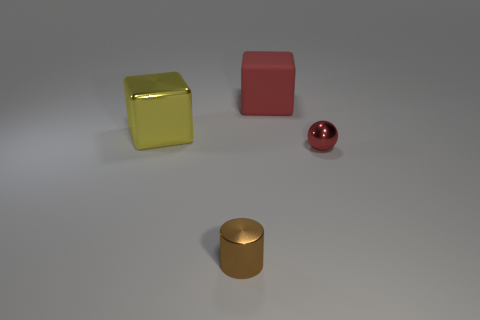There is another thing that is the same shape as the large yellow shiny object; what is its color?
Ensure brevity in your answer.  Red. What color is the large block that is made of the same material as the ball?
Your answer should be compact. Yellow. How many cylinders are the same size as the red sphere?
Make the answer very short. 1. What is the large yellow cube made of?
Make the answer very short. Metal. Are there more tiny brown metal cylinders than tiny blue metallic blocks?
Give a very brief answer. Yes. Does the tiny red metal object have the same shape as the large yellow object?
Give a very brief answer. No. Are there any other things that are the same shape as the brown thing?
Offer a very short reply. No. Do the big block that is to the right of the metallic cylinder and the tiny shiny thing that is in front of the tiny red thing have the same color?
Provide a short and direct response. No. Is the number of large yellow metallic objects behind the red matte cube less than the number of red rubber cubes that are on the left side of the big metal block?
Give a very brief answer. No. The small metal thing that is in front of the red shiny object has what shape?
Your response must be concise. Cylinder. 